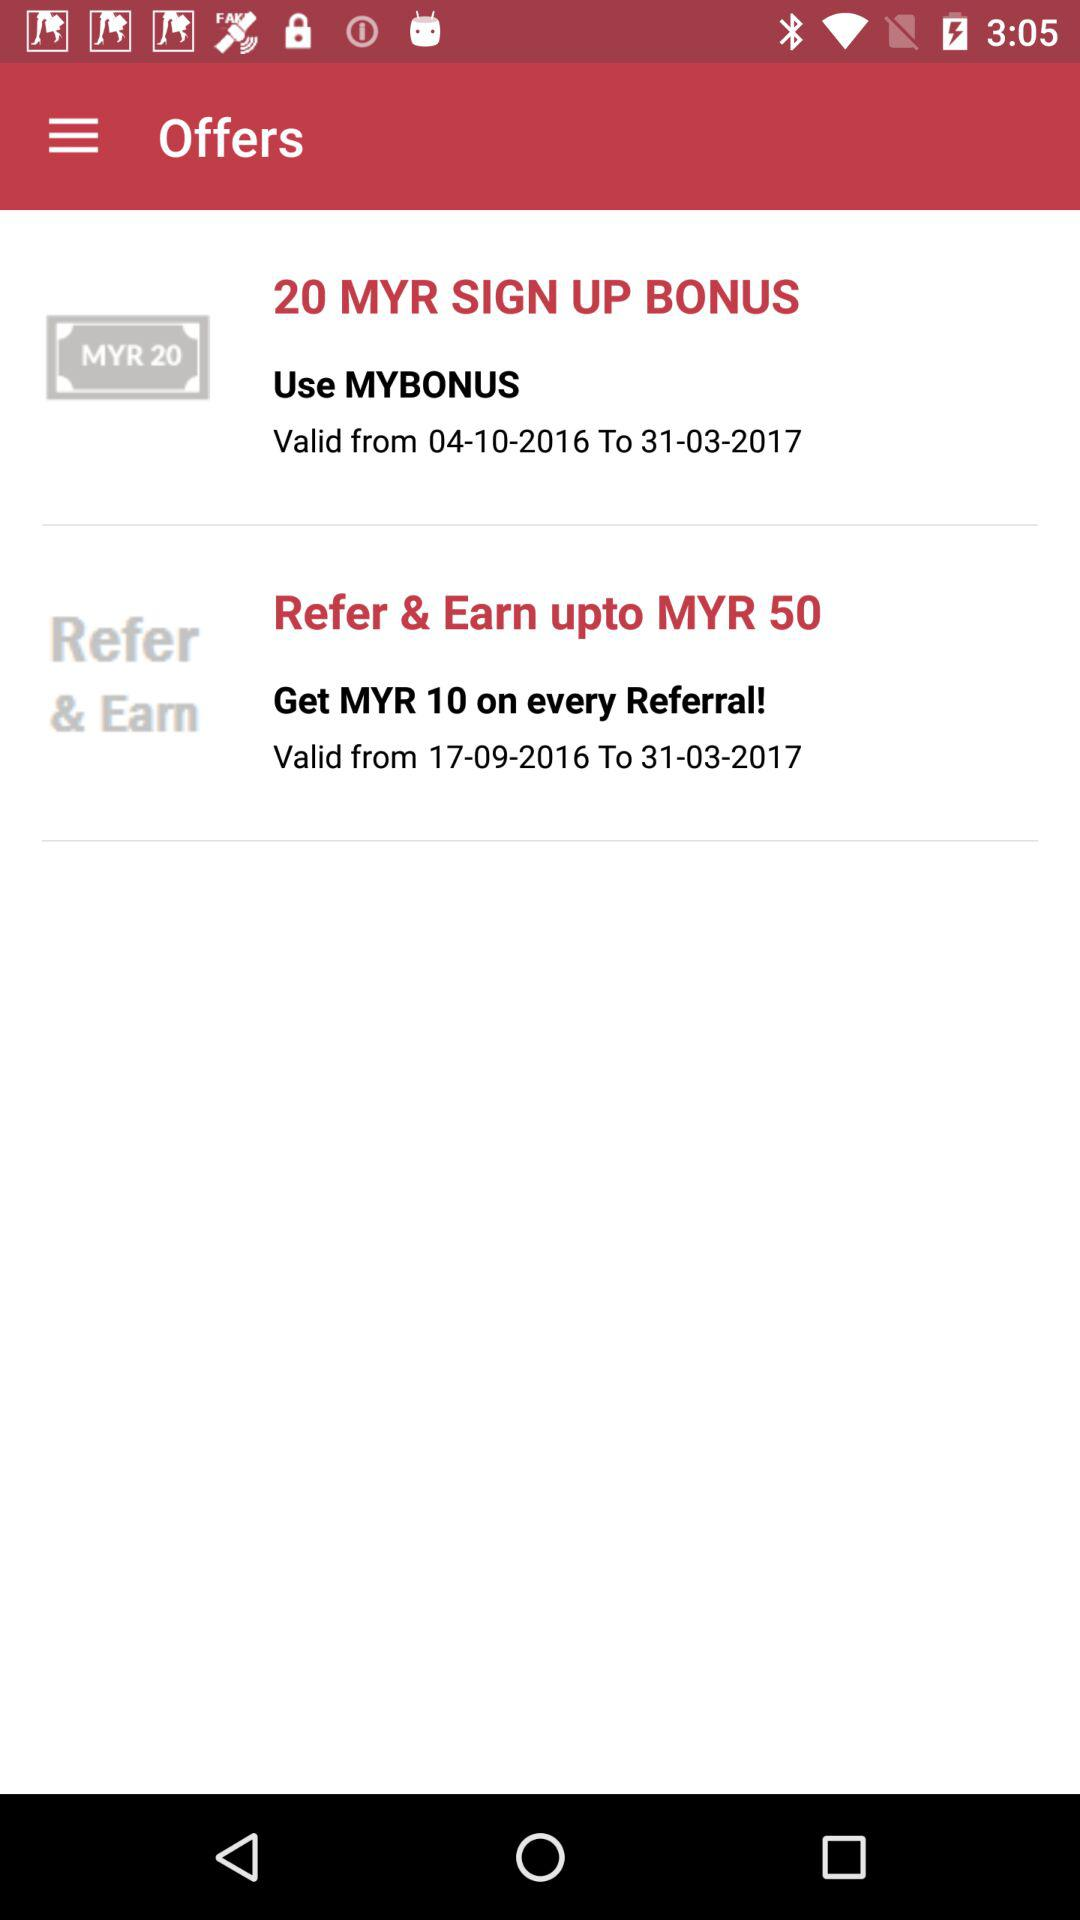For which period is the sign up bonus valid? The sign up bonus is valid between 04-10-2016 and 31-03-2017. 